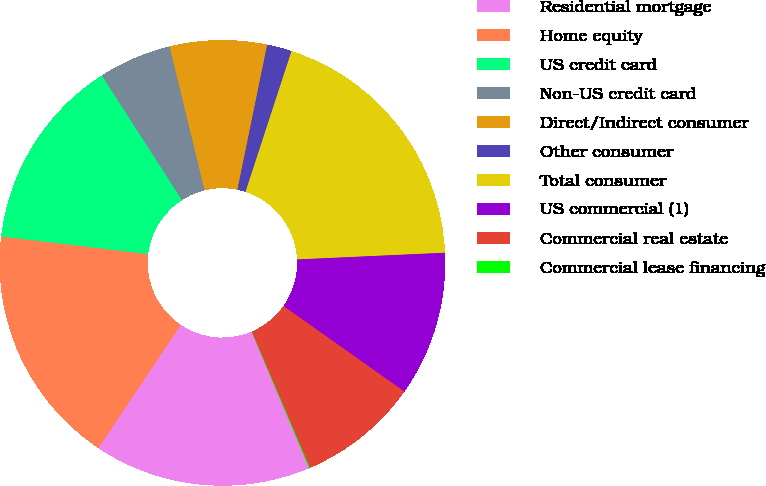Convert chart. <chart><loc_0><loc_0><loc_500><loc_500><pie_chart><fcel>Residential mortgage<fcel>Home equity<fcel>US credit card<fcel>Non-US credit card<fcel>Direct/Indirect consumer<fcel>Other consumer<fcel>Total consumer<fcel>US commercial (1)<fcel>Commercial real estate<fcel>Commercial lease financing<nl><fcel>15.76%<fcel>17.5%<fcel>14.01%<fcel>5.29%<fcel>7.03%<fcel>1.8%<fcel>19.25%<fcel>10.52%<fcel>8.78%<fcel>0.06%<nl></chart> 